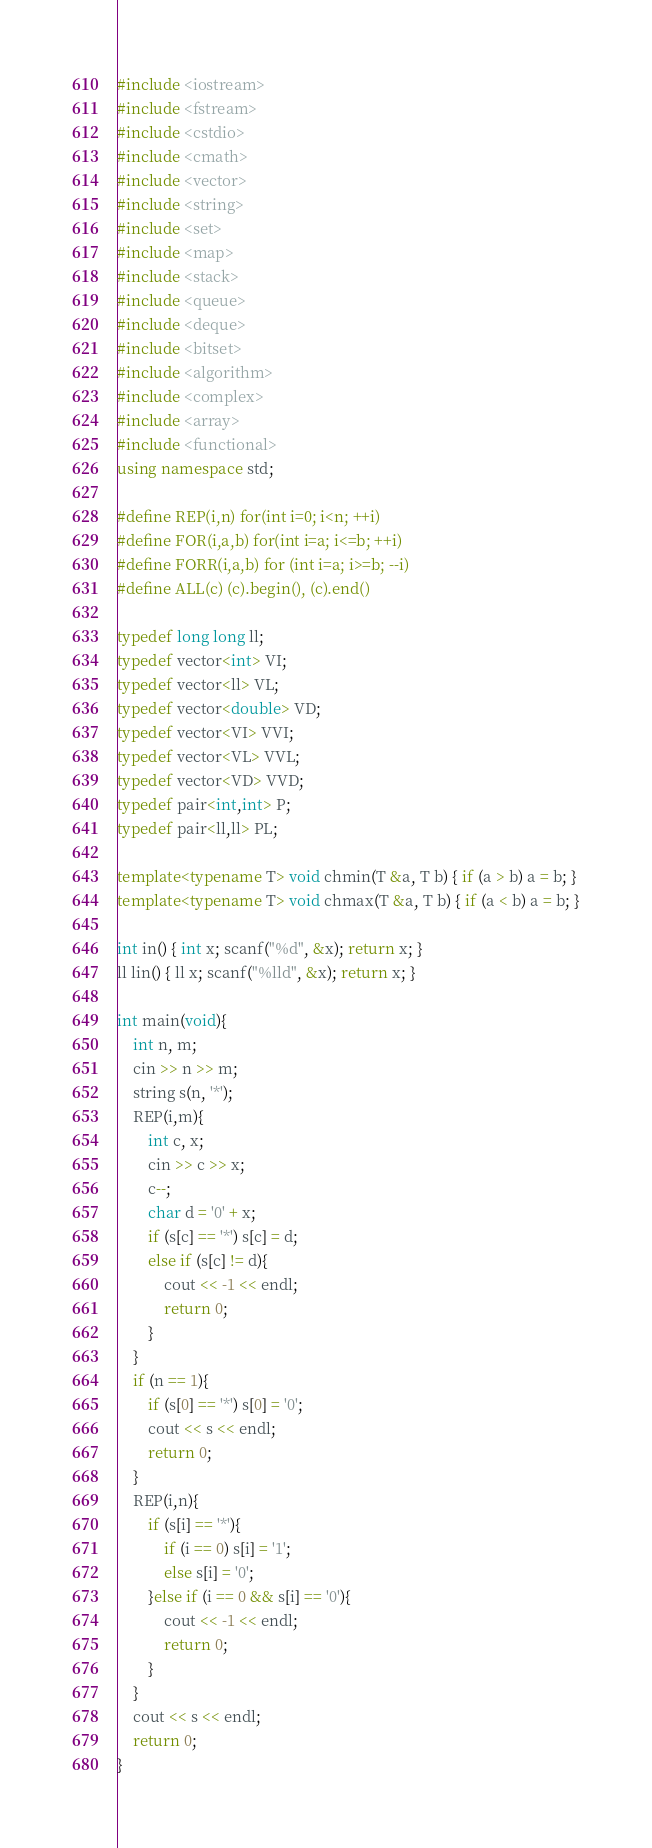<code> <loc_0><loc_0><loc_500><loc_500><_C++_>#include <iostream>
#include <fstream>
#include <cstdio>
#include <cmath>
#include <vector>
#include <string>
#include <set>
#include <map>
#include <stack>
#include <queue>
#include <deque>
#include <bitset>
#include <algorithm>
#include <complex>
#include <array>
#include <functional>
using namespace std;
 
#define REP(i,n) for(int i=0; i<n; ++i)
#define FOR(i,a,b) for(int i=a; i<=b; ++i)
#define FORR(i,a,b) for (int i=a; i>=b; --i)
#define ALL(c) (c).begin(), (c).end()
 
typedef long long ll;
typedef vector<int> VI;
typedef vector<ll> VL;
typedef vector<double> VD;
typedef vector<VI> VVI;
typedef vector<VL> VVL;
typedef vector<VD> VVD;
typedef pair<int,int> P;
typedef pair<ll,ll> PL;

template<typename T> void chmin(T &a, T b) { if (a > b) a = b; }
template<typename T> void chmax(T &a, T b) { if (a < b) a = b; }

int in() { int x; scanf("%d", &x); return x; }
ll lin() { ll x; scanf("%lld", &x); return x; }

int main(void){
    int n, m;
    cin >> n >> m;
    string s(n, '*');
    REP(i,m){
        int c, x;
        cin >> c >> x;
        c--;
        char d = '0' + x;
        if (s[c] == '*') s[c] = d;
        else if (s[c] != d){
            cout << -1 << endl;
            return 0;
        }
    }
    if (n == 1){
        if (s[0] == '*') s[0] = '0';
        cout << s << endl;
        return 0;
    }
    REP(i,n){
        if (s[i] == '*'){
            if (i == 0) s[i] = '1';
            else s[i] = '0';
        }else if (i == 0 && s[i] == '0'){
            cout << -1 << endl;
            return 0;
        }
    }
    cout << s << endl;
    return 0;
}
</code> 